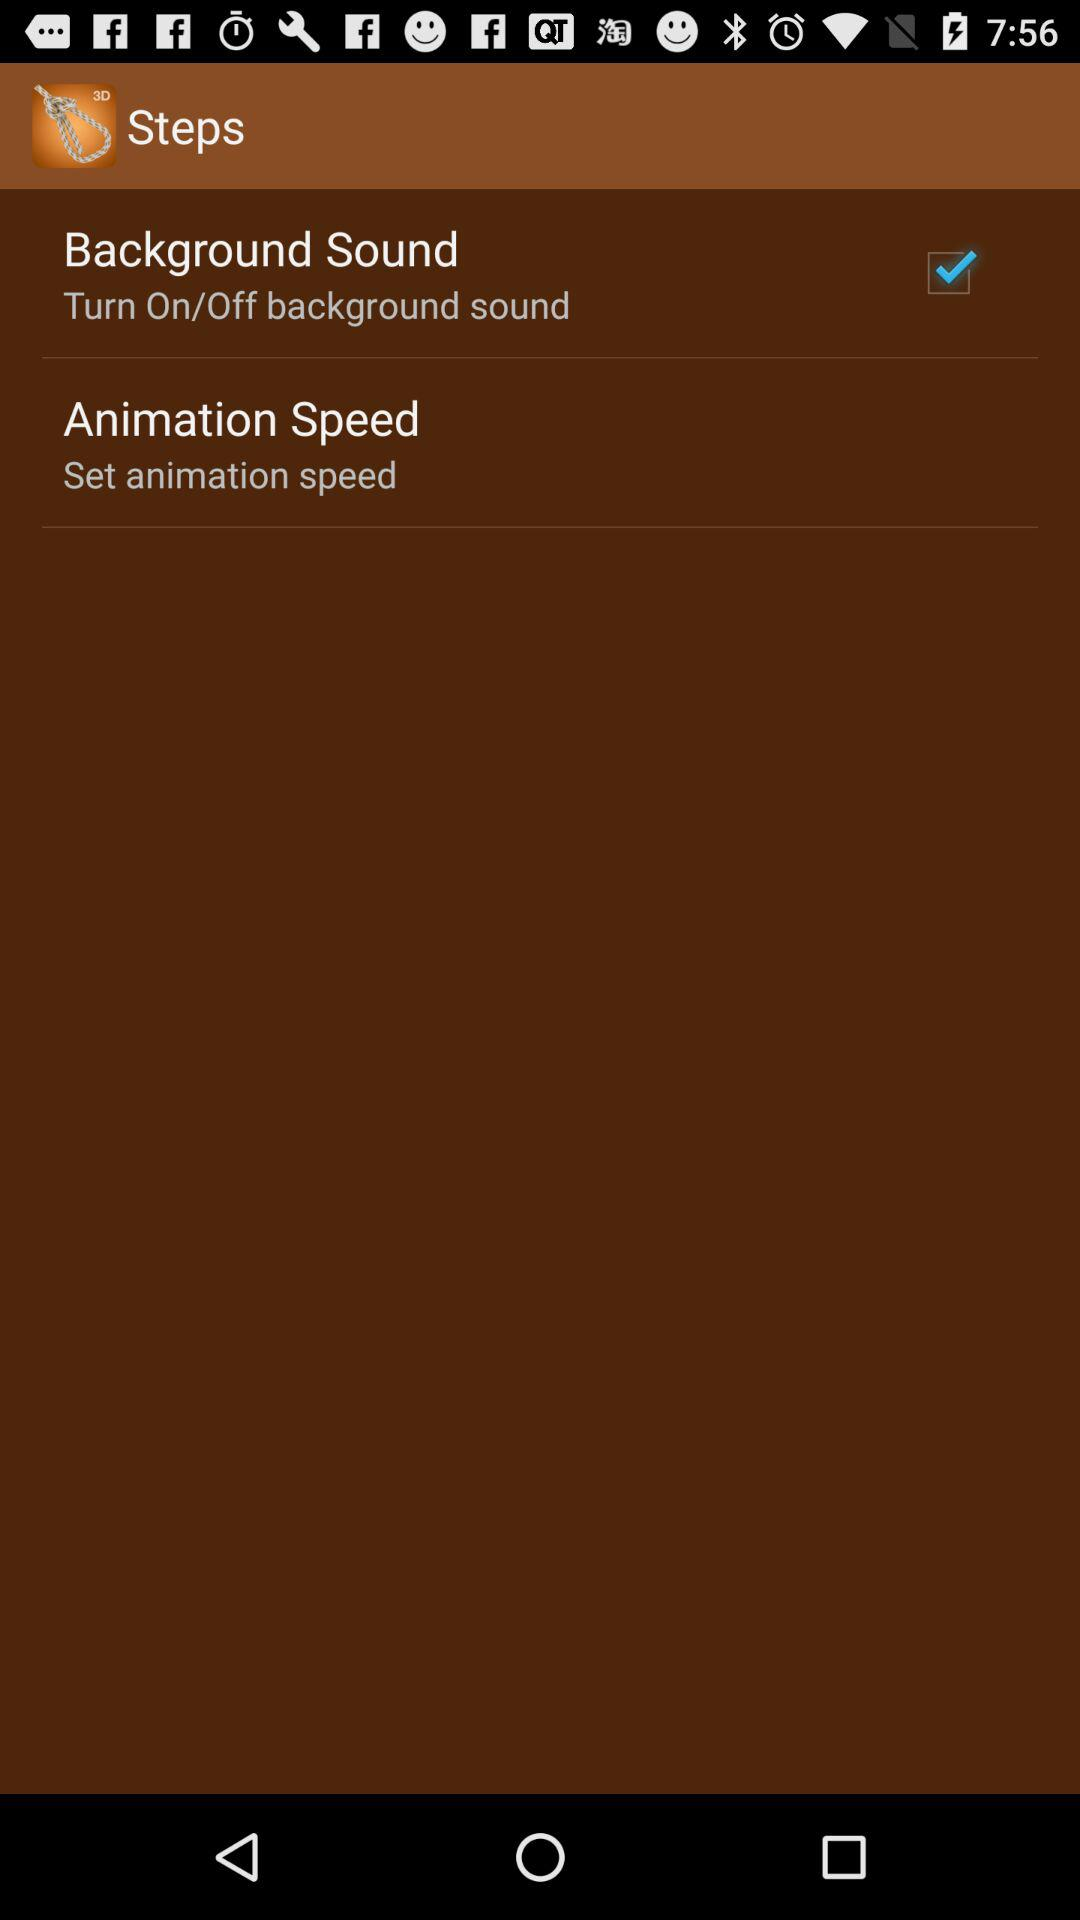What is the setting for "Background Sound"? The setting is on. 